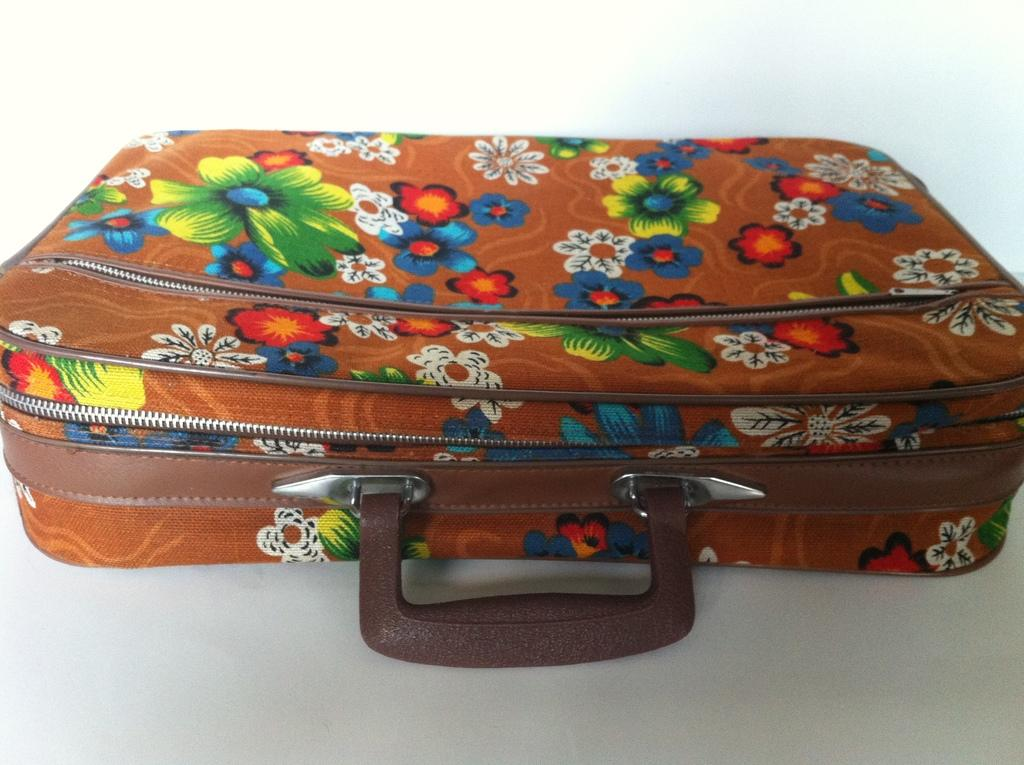What object can be seen in the image that people might use for traveling? There is a suitcase in the image that people might use for traveling. What design or pattern is on the suitcase? The suitcase has colorful pictures on it. What type of pipe can be seen sticking out of the suitcase in the image? There is no pipe present in the image; it only features a suitcase with colorful pictures on it. 